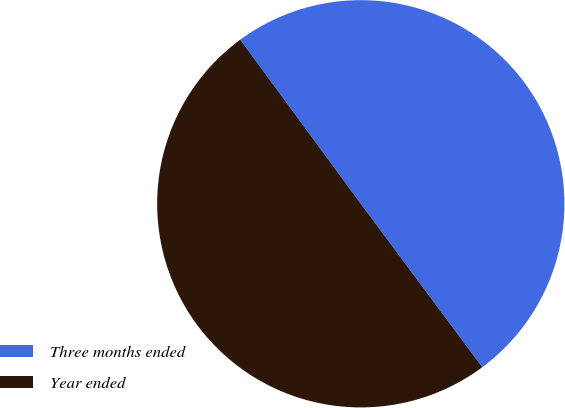Convert chart. <chart><loc_0><loc_0><loc_500><loc_500><pie_chart><fcel>Three months ended<fcel>Year ended<nl><fcel>49.91%<fcel>50.09%<nl></chart> 